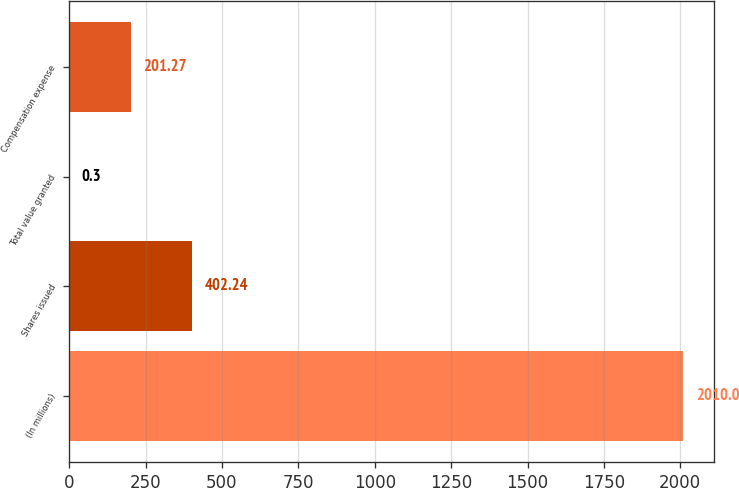<chart> <loc_0><loc_0><loc_500><loc_500><bar_chart><fcel>(In millions)<fcel>Shares issued<fcel>Total value granted<fcel>Compensation expense<nl><fcel>2010<fcel>402.24<fcel>0.3<fcel>201.27<nl></chart> 